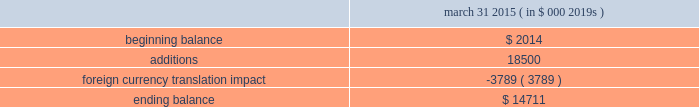Abiomed , inc .
And subsidiaries notes to consolidated financial statements 2014 ( continued ) note 8 .
Goodwill and in-process research and development ( continued ) the company has no accumulated impairment losses on goodwill .
The company performed a step 0 qualitative assessment during the annual impairment review for fiscal 2015 as of october 31 , 2014 and concluded that it is not more likely than not that the fair value of the company 2019s single reporting unit is less than its carrying amount .
Therefore , the two-step goodwill impairment test for the reporting unit was not necessary in fiscal 2015 .
As described in note 3 .
201cacquisitions , 201d in july 2014 , the company acquired ecp and ais and recorded $ 18.5 million of ipr&d .
The estimated fair value of the ipr&d was determined using a probability-weighted income approach , which discounts expected future cash flows to present value .
The projected cash flows from the expandable catheter pump technology were based on certain key assumptions , including estimates of future revenue and expenses , taking into account the stage of development of the technology at the acquisition date and the time and resources needed to complete development .
The company used a discount rate of 22.5% ( 22.5 % ) and cash flows that have been probability adjusted to reflect the risks of product commercialization , which the company believes are appropriate and representative of market participant assumptions .
The carrying value of the company 2019s ipr&d assets and the change in the balance for the year ended march 31 , 2015 is as follows : march 31 , ( in $ 000 2019s ) .
Note 9 .
Stockholders 2019 equity class b preferred stock the company has authorized 1000000 shares of class b preferred stock , $ .01 par value , of which the board of directors can set the designation , rights and privileges .
No shares of class b preferred stock have been issued or are outstanding .
Stock repurchase program in november 2012 , the company 2019s board of directors authorized a stock repurchase program for up to $ 15.0 million of its common stock .
The company financed the stock repurchase program with its available cash .
During the year ended march 31 , 2013 , the company repurchased 1123587 shares for $ 15.0 million in open market purchases at an average cost of $ 13.39 per share , including commission expense .
The company completed the purchase of common stock under this stock repurchase program in january 2013 .
Note 10 .
Stock award plans and stock-based compensation stock award plans the company grants stock options and restricted stock awards to employees and others .
All outstanding stock options of the company as of march 31 , 2015 were granted with an exercise price equal to the fair market value on the date of grant .
Outstanding stock options , if not exercised , expire 10 years from the date of grant .
The company 2019s 2008 stock incentive plan ( the 201cplan 201d ) authorizes the grant of a variety of equity awards to the company 2019s officers , directors , employees , consultants and advisers , including awards of unrestricted and restricted stock , restricted stock units , incentive and nonqualified stock options to purchase shares of common stock , performance share awards and stock appreciation rights .
The plan provides that options may only be granted at the current market value on the date of grant .
Each share of stock issued pursuant to a stock option or stock appreciation right counts as one share against the maximum number of shares issuable under the plan , while each share of stock issued .
What is the percentage decrease in carrying value of ipr&d assets due to foreign currency impact? 
Computations: (-3789 / 18500)
Answer: -0.20481. 